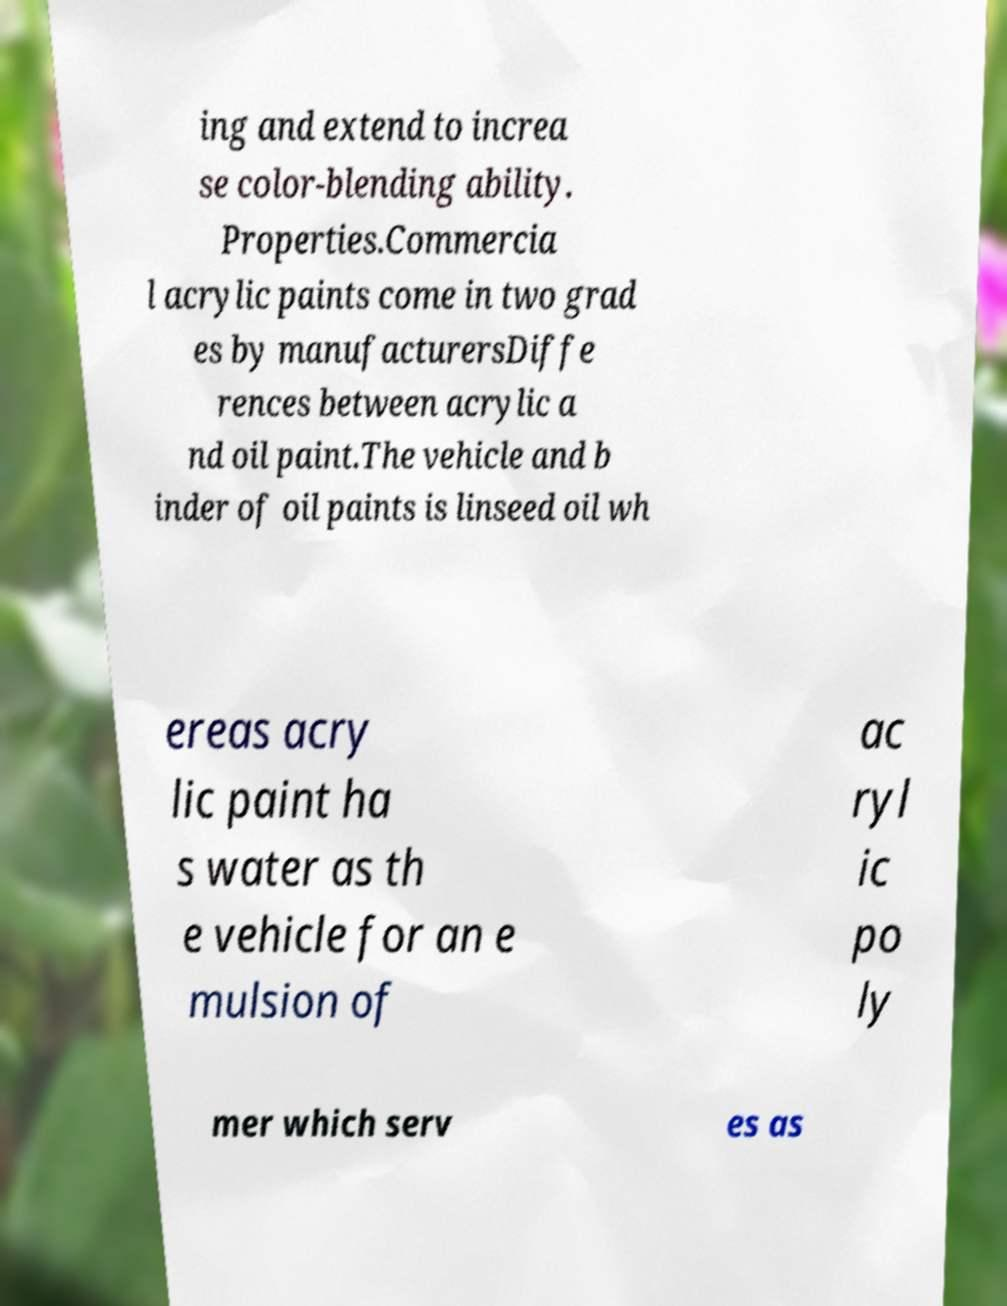Can you read and provide the text displayed in the image?This photo seems to have some interesting text. Can you extract and type it out for me? ing and extend to increa se color-blending ability. Properties.Commercia l acrylic paints come in two grad es by manufacturersDiffe rences between acrylic a nd oil paint.The vehicle and b inder of oil paints is linseed oil wh ereas acry lic paint ha s water as th e vehicle for an e mulsion of ac ryl ic po ly mer which serv es as 